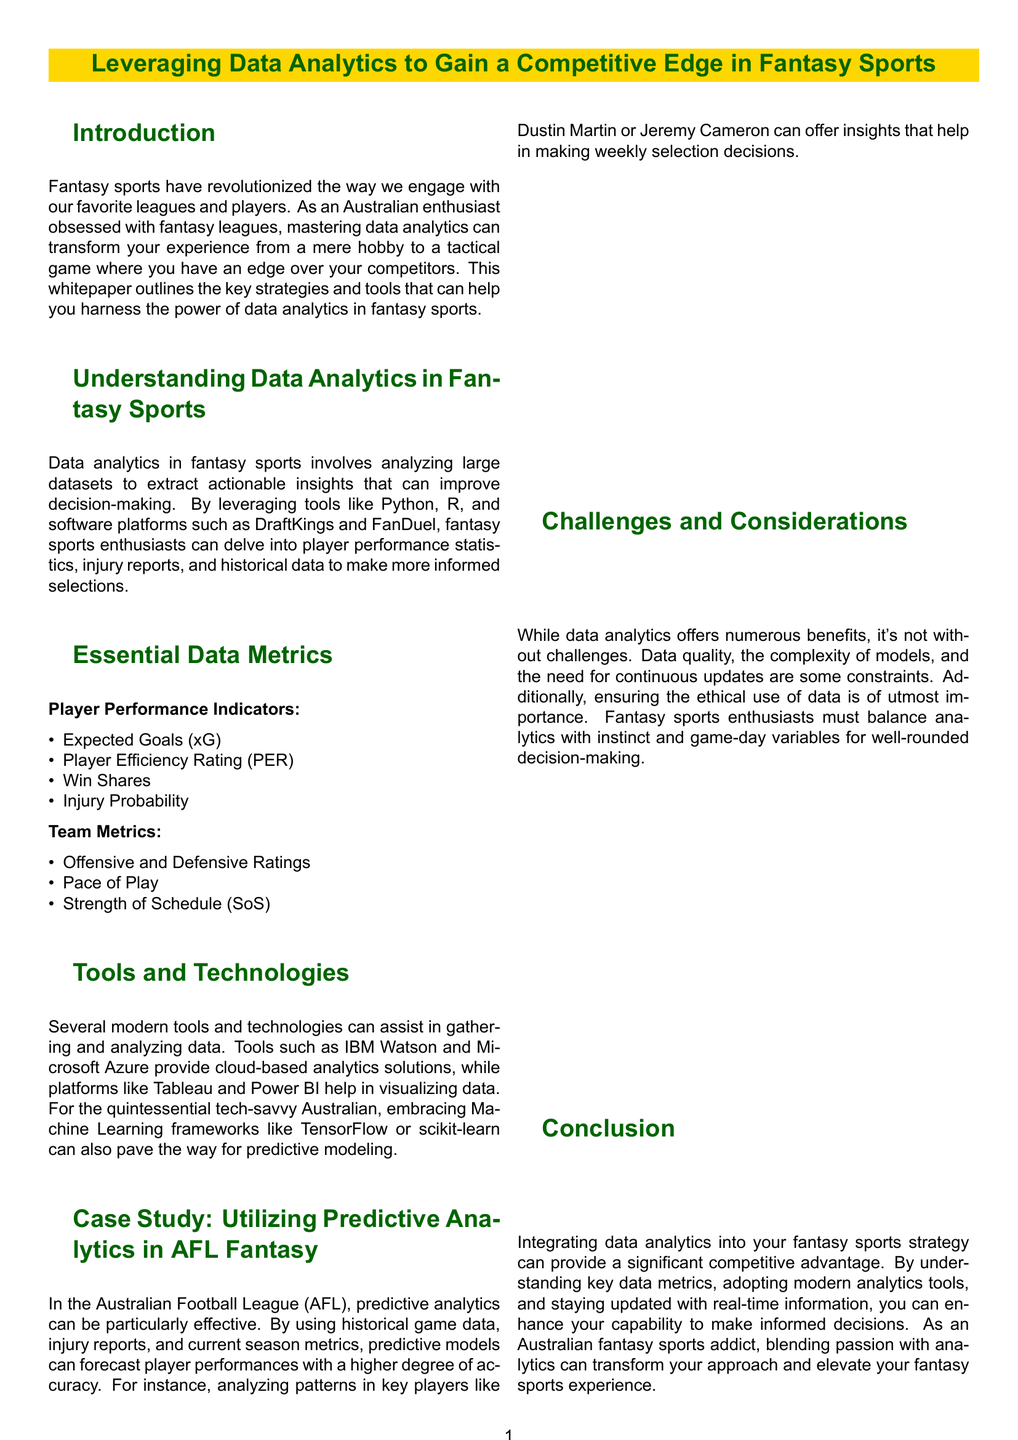What is the title of the whitepaper? The title is aimed at understanding the use of data analytics in fantasy sports for competitive advantage.
Answer: Leveraging Data Analytics to Gain a Competitive Edge in Fantasy Sports What does xG stand for? xG is a common metric in evaluating player performance related to goal scoring.
Answer: Expected Goals Name one tool used for data visualization mentioned in the document. The document lists several tools that aid in visualizing data analytics results.
Answer: Tableau In which league is the case study focused? The case study illustrates the application of predictive analytics in a specific Australian league.
Answer: AFL What is a challenge associated with data analytics in fantasy sports? The challenges of using data analytics have been outlined, focusing on a few typical pitfalls that users encounter.
Answer: Data quality How can data analytics enhance decision-making in fantasy sports? The document discusses the transformative effect of data analytics on how enthusiasts approach player selections and team management.
Answer: Improve decision-making What is one example of a player performance indicator? The document enumerates various metrics used to evaluate player performance in fantasy sports.
Answer: Win Shares What should fantasy sports enthusiasts balance with analytics? The document emphasizes the importance of integrating different aspects into the decision-making process.
Answer: Instinct and game-day variables 